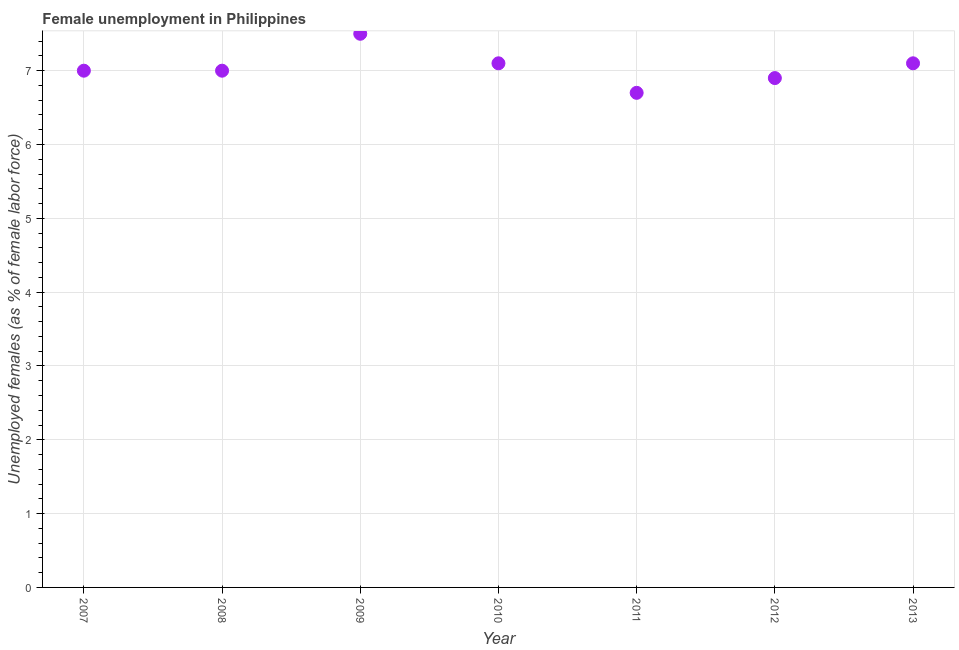What is the unemployed females population in 2013?
Your answer should be compact. 7.1. Across all years, what is the minimum unemployed females population?
Make the answer very short. 6.7. In which year was the unemployed females population minimum?
Your answer should be compact. 2011. What is the sum of the unemployed females population?
Keep it short and to the point. 49.3. What is the difference between the unemployed females population in 2008 and 2010?
Offer a terse response. -0.1. What is the average unemployed females population per year?
Keep it short and to the point. 7.04. What is the ratio of the unemployed females population in 2008 to that in 2009?
Ensure brevity in your answer.  0.93. Is the difference between the unemployed females population in 2011 and 2012 greater than the difference between any two years?
Keep it short and to the point. No. What is the difference between the highest and the second highest unemployed females population?
Make the answer very short. 0.4. Is the sum of the unemployed females population in 2007 and 2013 greater than the maximum unemployed females population across all years?
Your response must be concise. Yes. What is the difference between the highest and the lowest unemployed females population?
Offer a terse response. 0.8. How many dotlines are there?
Provide a succinct answer. 1. How many years are there in the graph?
Ensure brevity in your answer.  7. What is the difference between two consecutive major ticks on the Y-axis?
Your answer should be very brief. 1. Does the graph contain any zero values?
Provide a succinct answer. No. Does the graph contain grids?
Offer a very short reply. Yes. What is the title of the graph?
Keep it short and to the point. Female unemployment in Philippines. What is the label or title of the Y-axis?
Your answer should be compact. Unemployed females (as % of female labor force). What is the Unemployed females (as % of female labor force) in 2007?
Make the answer very short. 7. What is the Unemployed females (as % of female labor force) in 2009?
Give a very brief answer. 7.5. What is the Unemployed females (as % of female labor force) in 2010?
Offer a terse response. 7.1. What is the Unemployed females (as % of female labor force) in 2011?
Give a very brief answer. 6.7. What is the Unemployed females (as % of female labor force) in 2012?
Offer a terse response. 6.9. What is the Unemployed females (as % of female labor force) in 2013?
Provide a short and direct response. 7.1. What is the difference between the Unemployed females (as % of female labor force) in 2007 and 2010?
Offer a very short reply. -0.1. What is the difference between the Unemployed females (as % of female labor force) in 2007 and 2013?
Keep it short and to the point. -0.1. What is the difference between the Unemployed females (as % of female labor force) in 2008 and 2009?
Offer a very short reply. -0.5. What is the difference between the Unemployed females (as % of female labor force) in 2008 and 2011?
Your answer should be compact. 0.3. What is the difference between the Unemployed females (as % of female labor force) in 2008 and 2012?
Provide a succinct answer. 0.1. What is the difference between the Unemployed females (as % of female labor force) in 2008 and 2013?
Make the answer very short. -0.1. What is the difference between the Unemployed females (as % of female labor force) in 2009 and 2013?
Make the answer very short. 0.4. What is the difference between the Unemployed females (as % of female labor force) in 2010 and 2011?
Offer a very short reply. 0.4. What is the difference between the Unemployed females (as % of female labor force) in 2010 and 2012?
Ensure brevity in your answer.  0.2. What is the ratio of the Unemployed females (as % of female labor force) in 2007 to that in 2008?
Give a very brief answer. 1. What is the ratio of the Unemployed females (as % of female labor force) in 2007 to that in 2009?
Provide a succinct answer. 0.93. What is the ratio of the Unemployed females (as % of female labor force) in 2007 to that in 2011?
Ensure brevity in your answer.  1.04. What is the ratio of the Unemployed females (as % of female labor force) in 2007 to that in 2013?
Provide a short and direct response. 0.99. What is the ratio of the Unemployed females (as % of female labor force) in 2008 to that in 2009?
Make the answer very short. 0.93. What is the ratio of the Unemployed females (as % of female labor force) in 2008 to that in 2010?
Your answer should be compact. 0.99. What is the ratio of the Unemployed females (as % of female labor force) in 2008 to that in 2011?
Ensure brevity in your answer.  1.04. What is the ratio of the Unemployed females (as % of female labor force) in 2008 to that in 2012?
Provide a succinct answer. 1.01. What is the ratio of the Unemployed females (as % of female labor force) in 2008 to that in 2013?
Your answer should be compact. 0.99. What is the ratio of the Unemployed females (as % of female labor force) in 2009 to that in 2010?
Offer a very short reply. 1.06. What is the ratio of the Unemployed females (as % of female labor force) in 2009 to that in 2011?
Keep it short and to the point. 1.12. What is the ratio of the Unemployed females (as % of female labor force) in 2009 to that in 2012?
Provide a succinct answer. 1.09. What is the ratio of the Unemployed females (as % of female labor force) in 2009 to that in 2013?
Your answer should be compact. 1.06. What is the ratio of the Unemployed females (as % of female labor force) in 2010 to that in 2011?
Offer a very short reply. 1.06. What is the ratio of the Unemployed females (as % of female labor force) in 2010 to that in 2013?
Your answer should be very brief. 1. What is the ratio of the Unemployed females (as % of female labor force) in 2011 to that in 2012?
Keep it short and to the point. 0.97. What is the ratio of the Unemployed females (as % of female labor force) in 2011 to that in 2013?
Give a very brief answer. 0.94. What is the ratio of the Unemployed females (as % of female labor force) in 2012 to that in 2013?
Your answer should be very brief. 0.97. 